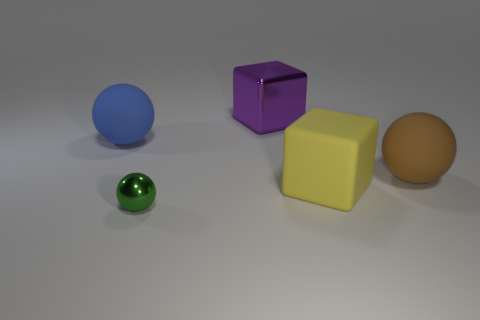What color is the sphere that is on the right side of the metallic object that is on the left side of the large block behind the yellow rubber object? The sphere you're referring to appears to be blue, not brown. It is positioned to the right of the metallic purple cube, which in turn is to the left of the large beige block located behind the small yellow cube. 